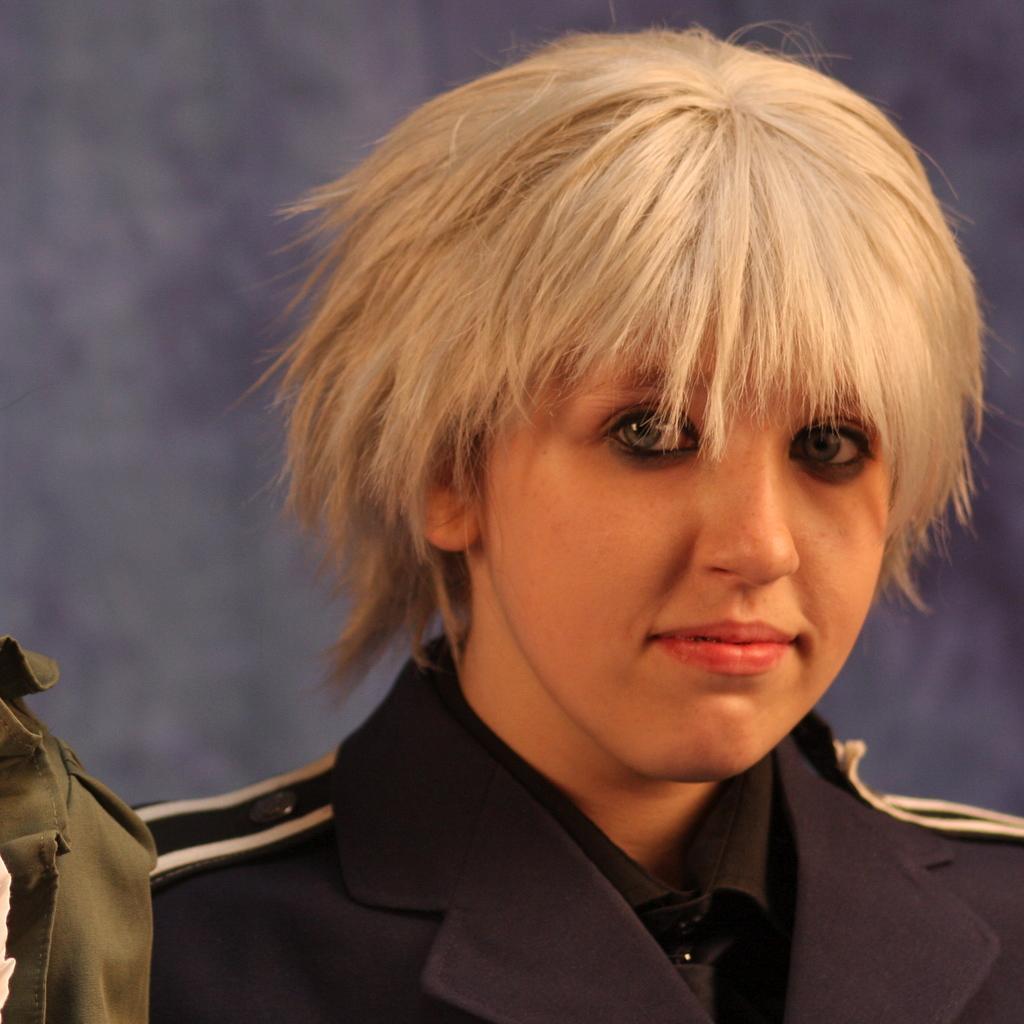Can you describe this image briefly? In the center of the image, we can see a person wearing uniform and we can see a cloth. In the background, there is a wall. 